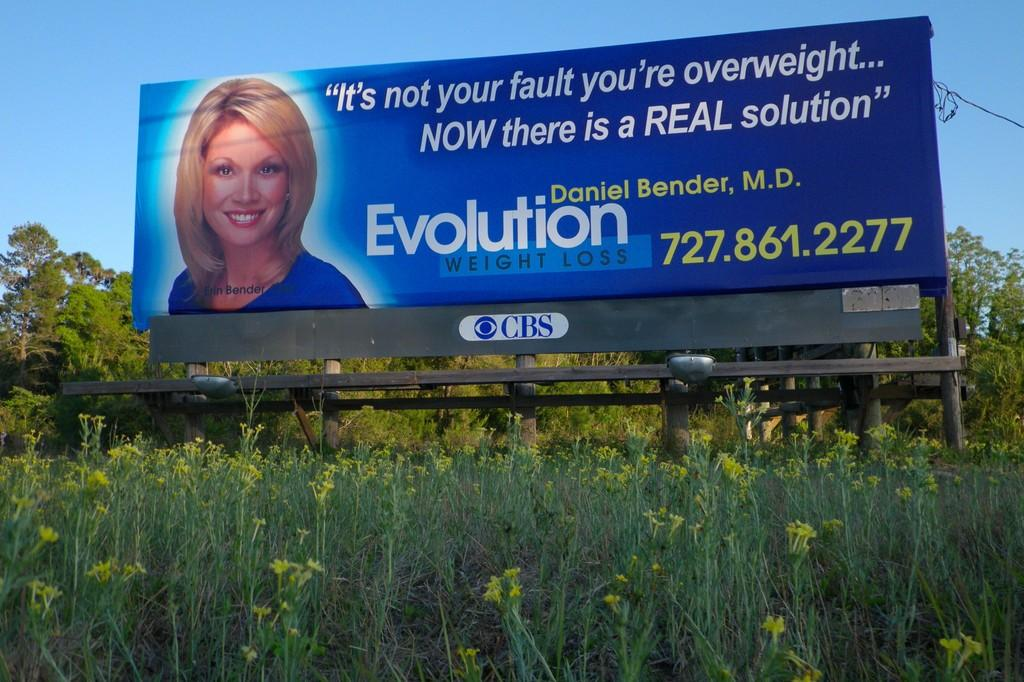<image>
Describe the image concisely. the word evolution is on a sign outside 